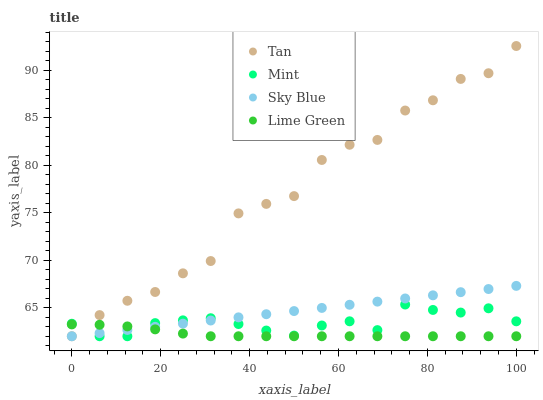Does Lime Green have the minimum area under the curve?
Answer yes or no. Yes. Does Tan have the maximum area under the curve?
Answer yes or no. Yes. Does Mint have the minimum area under the curve?
Answer yes or no. No. Does Mint have the maximum area under the curve?
Answer yes or no. No. Is Sky Blue the smoothest?
Answer yes or no. Yes. Is Tan the roughest?
Answer yes or no. Yes. Is Mint the smoothest?
Answer yes or no. No. Is Mint the roughest?
Answer yes or no. No. Does Sky Blue have the lowest value?
Answer yes or no. Yes. Does Tan have the highest value?
Answer yes or no. Yes. Does Mint have the highest value?
Answer yes or no. No. Does Lime Green intersect Sky Blue?
Answer yes or no. Yes. Is Lime Green less than Sky Blue?
Answer yes or no. No. Is Lime Green greater than Sky Blue?
Answer yes or no. No. 